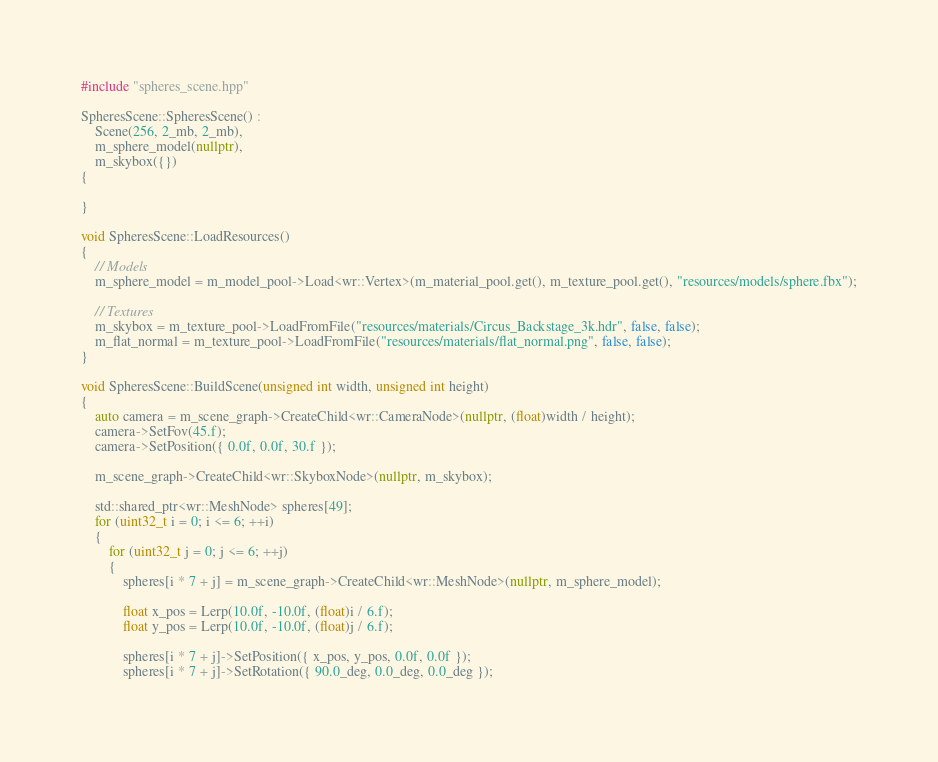<code> <loc_0><loc_0><loc_500><loc_500><_C++_>
#include "spheres_scene.hpp"

SpheresScene::SpheresScene() :
	Scene(256, 2_mb, 2_mb),
	m_sphere_model(nullptr),
	m_skybox({})
{

}

void SpheresScene::LoadResources()
{
	// Models
	m_sphere_model = m_model_pool->Load<wr::Vertex>(m_material_pool.get(), m_texture_pool.get(), "resources/models/sphere.fbx");

	// Textures
	m_skybox = m_texture_pool->LoadFromFile("resources/materials/Circus_Backstage_3k.hdr", false, false);
	m_flat_normal = m_texture_pool->LoadFromFile("resources/materials/flat_normal.png", false, false);
}

void SpheresScene::BuildScene(unsigned int width, unsigned int height)
{
	auto camera = m_scene_graph->CreateChild<wr::CameraNode>(nullptr, (float)width / height);
	camera->SetFov(45.f);
	camera->SetPosition({ 0.0f, 0.0f, 30.f });

	m_scene_graph->CreateChild<wr::SkyboxNode>(nullptr, m_skybox);

	std::shared_ptr<wr::MeshNode> spheres[49];
	for (uint32_t i = 0; i <= 6; ++i)
	{
		for (uint32_t j = 0; j <= 6; ++j)
		{
			spheres[i * 7 + j] = m_scene_graph->CreateChild<wr::MeshNode>(nullptr, m_sphere_model);

			float x_pos = Lerp(10.0f, -10.0f, (float)i / 6.f);
			float y_pos = Lerp(10.0f, -10.0f, (float)j / 6.f);

			spheres[i * 7 + j]->SetPosition({ x_pos, y_pos, 0.0f, 0.0f });
			spheres[i * 7 + j]->SetRotation({ 90.0_deg, 0.0_deg, 0.0_deg });
</code> 